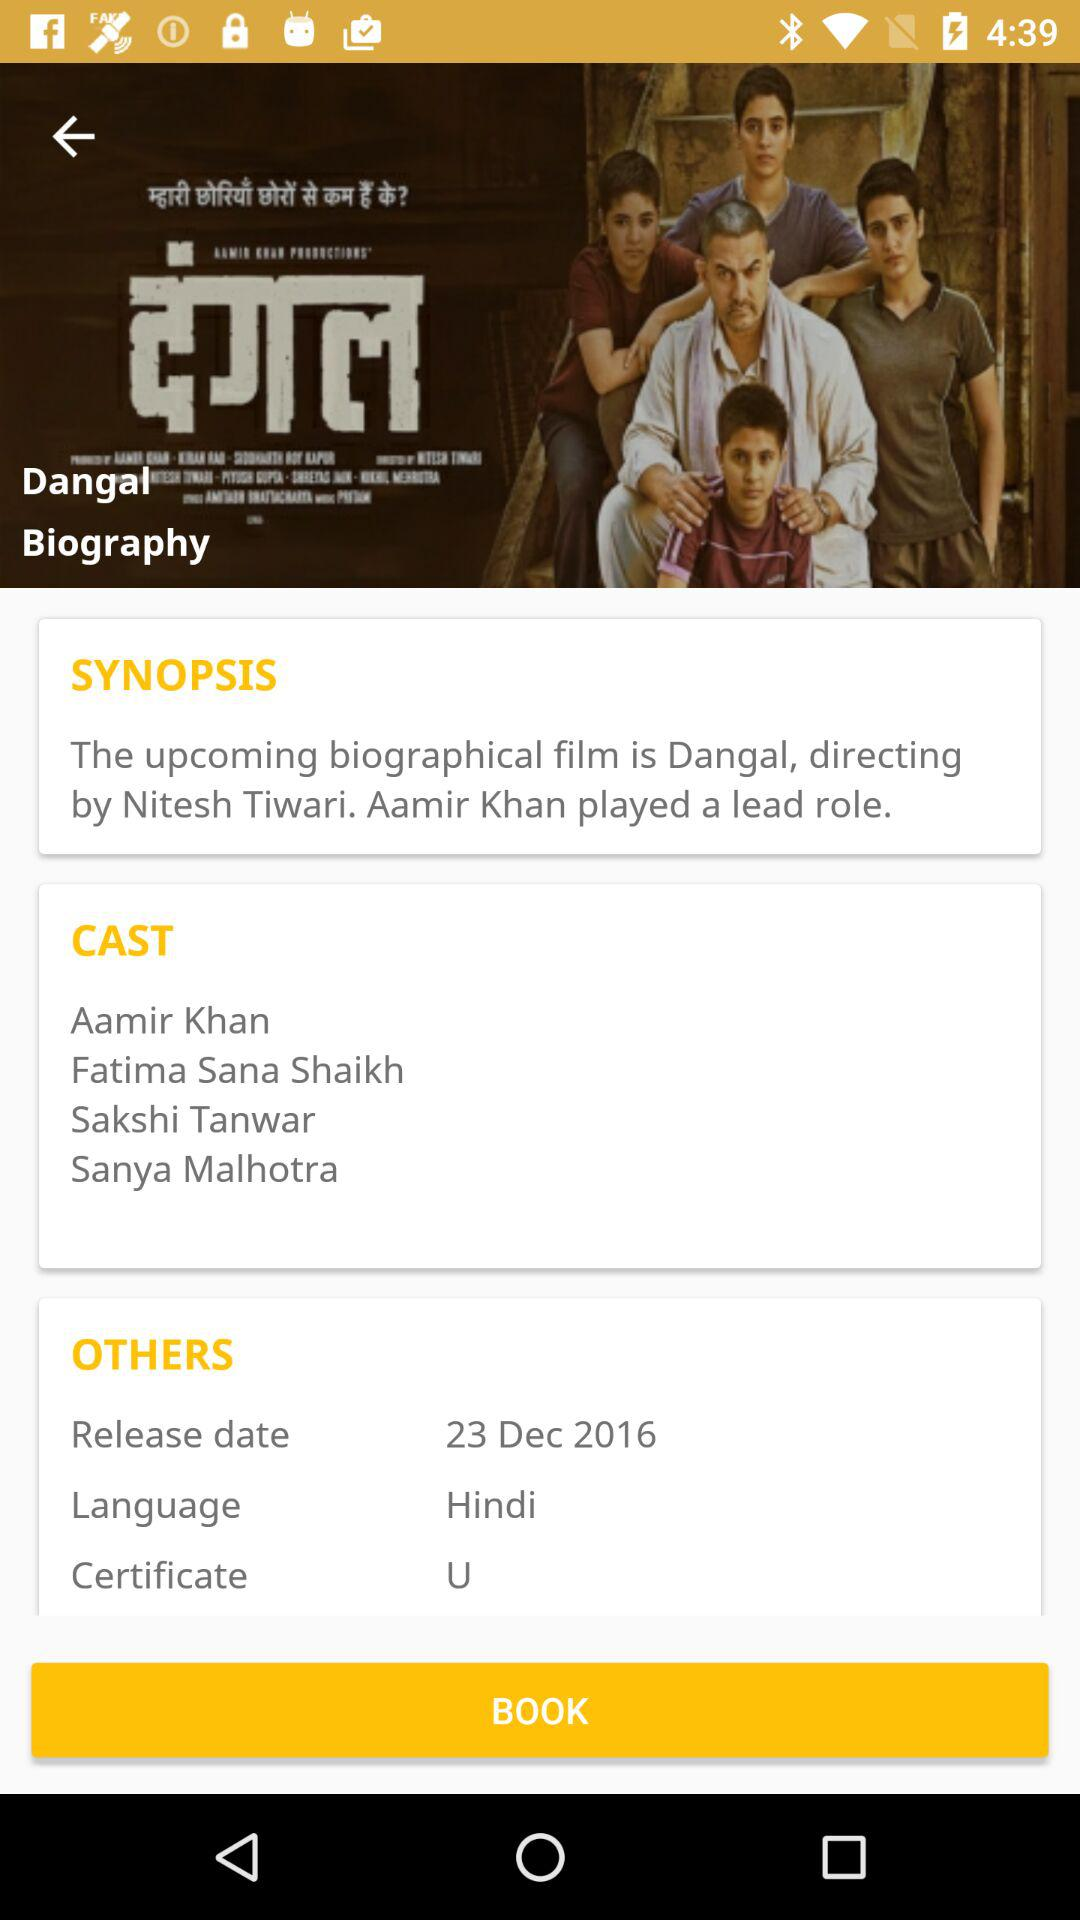What is the cast name? The cast includes Aamir Khan, Fatima Sana Shaikh, Sakshi Tanwar and Sanya Malhotra. 